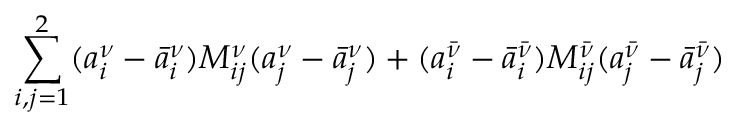<formula> <loc_0><loc_0><loc_500><loc_500>\sum _ { i , j = 1 } ^ { 2 } ( a _ { i } ^ { \nu } - \bar { a } _ { i } ^ { \nu } ) M _ { i j } ^ { \nu } ( a _ { j } ^ { \nu } - \bar { a } _ { j } ^ { \nu } ) + ( a _ { i } ^ { \bar { \nu } } - \bar { a } _ { i } ^ { \bar { \nu } } ) M _ { i j } ^ { \bar { \nu } } ( a _ { j } ^ { \bar { \nu } } - \bar { a } _ { j } ^ { \bar { \nu } } )</formula> 